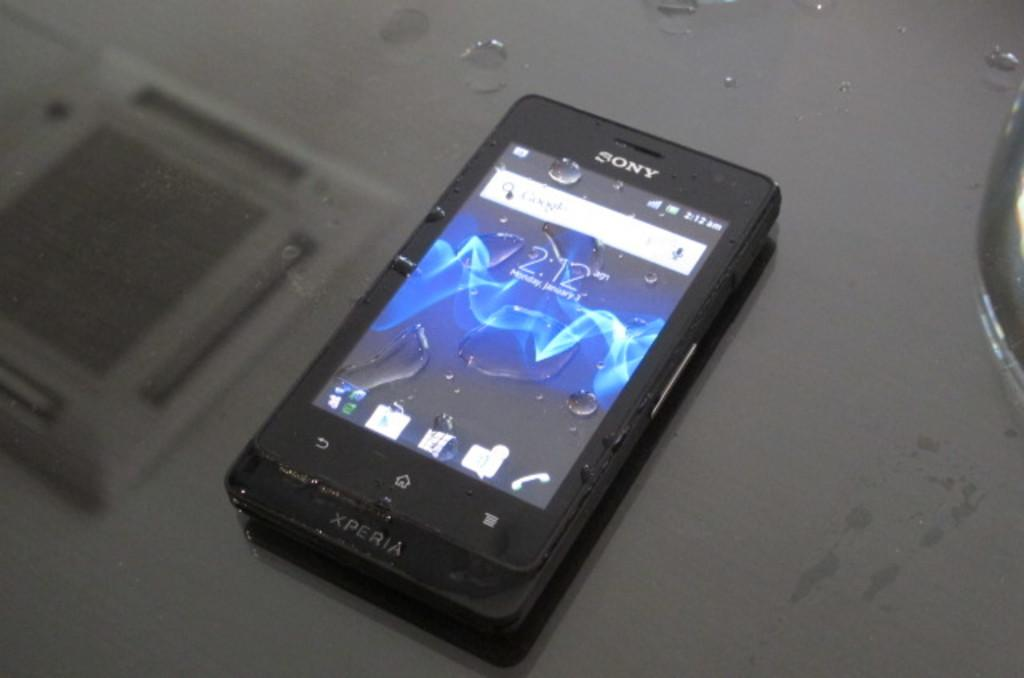<image>
Offer a succinct explanation of the picture presented. the word Sony is on a phone with many icons 